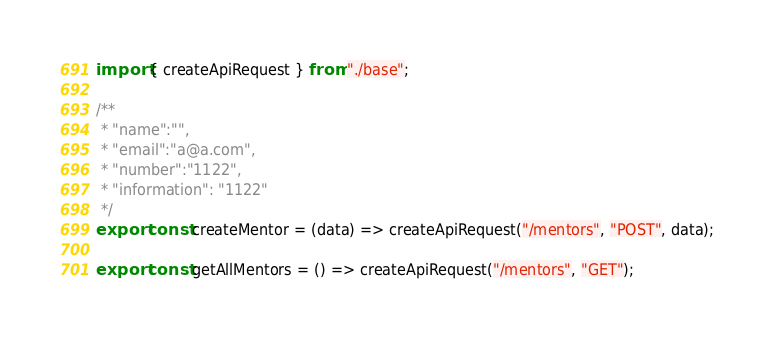Convert code to text. <code><loc_0><loc_0><loc_500><loc_500><_JavaScript_>import { createApiRequest } from "./base";

/**
 * "name":"",
 * "email":"a@a.com",
 * "number":"1122",
 * "information": "1122"
 */
export const createMentor = (data) => createApiRequest("/mentors", "POST", data);

export const getAllMentors = () => createApiRequest("/mentors", "GET");
</code> 